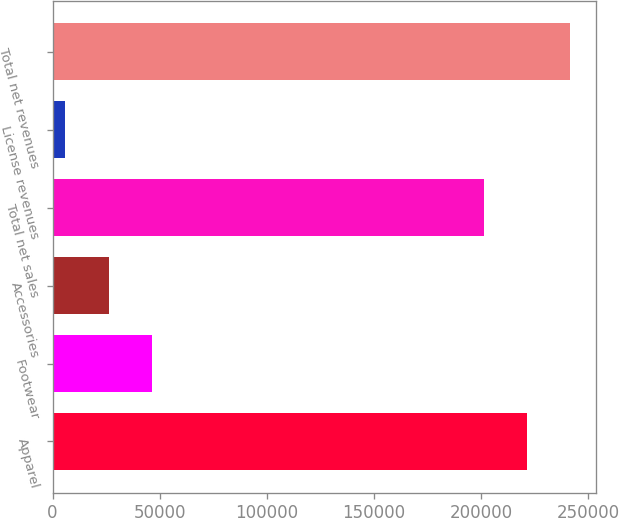Convert chart. <chart><loc_0><loc_0><loc_500><loc_500><bar_chart><fcel>Apparel<fcel>Footwear<fcel>Accessories<fcel>Total net sales<fcel>License revenues<fcel>Total net revenues<nl><fcel>221617<fcel>46340<fcel>26193<fcel>201470<fcel>6046<fcel>241764<nl></chart> 